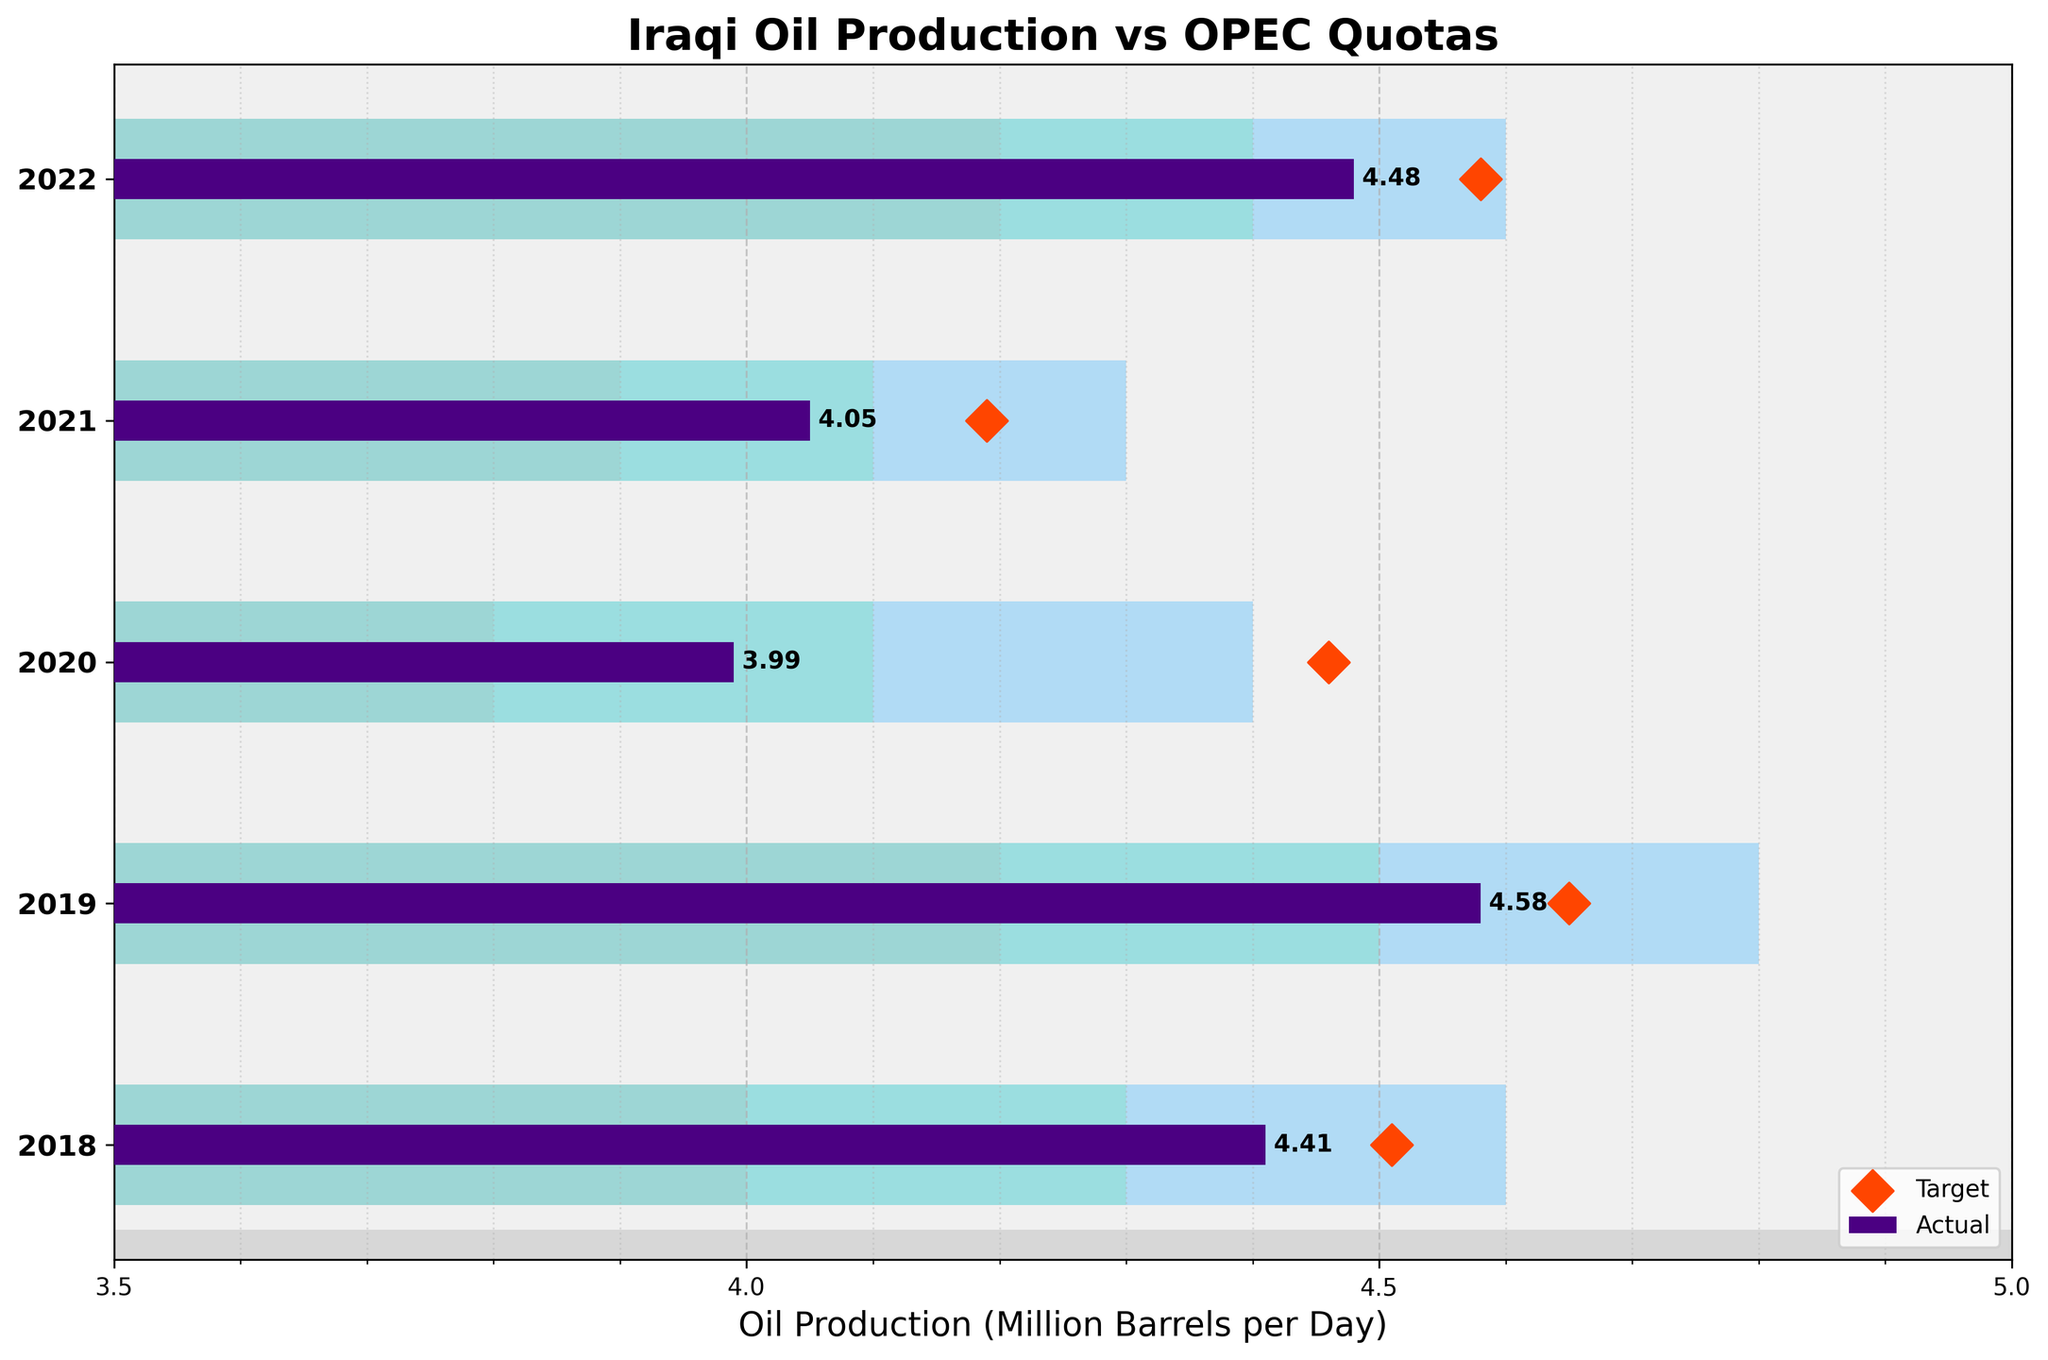What is the title of the figure? The title is usually located at the top of the figure. In this case, the title is "Iraqi Oil Production vs OPEC Quotas".
Answer: Iraqi Oil Production vs OPEC Quotas How many years of data are represented in the figure? The y-axis labels represent the categories, which are the years 2018, 2019, 2020, 2021, and 2022.
Answer: 5 What is the actual oil production value for 2019? The bar for 2019 corresponds to the value labeled on the x-axis just to the right of it. According to the labels, the value is 4.58 million barrels per day.
Answer: 4.58 million barrels per day What color represents the actual values in the figure? The legend indicates that the actual values are represented by a dark purple color in the figure.
Answer: Dark purple Which year had the highest actual oil production? By comparing the lengths of the dark purple bars, 2019 had the highest actual value, which is 4.58 million barrels per day.
Answer: 2019 For which year were actual oil production levels below all three thresholds? The actual production value should fall below the smallest threshold value. In 2020, the actual value (3.99) is below Threshold1 (3.8) because it is not represented beyond the light color gradient starting at 3.8.
Answer: 2020 How close was the actual value to the target in 2021? In 2021, the actual value is 4.05 and the target is 4.19. The difference is 4.19 - 4.05 = 0.14.
Answer: 0.14 million barrels per day In which year did Iraq exceed the target production quota? The actual production bar should extend beyond the target marker. In the figure, none of the purple bars are longer than the orange diamond markers. Thus, Iraq did not exceed its target production in any year.
Answer: None What is the overall trend of Iraqi oil production from 2018 to 2022? Evaluating the progression of the bars from 2018 to 2022 shows variability with a slight dip in 2020 and gradual recovery towards 2022, but no clear upward or downward trend.
Answer: Variable What is the smallest threshold value color? The thresholds are represented by three color shades. The smallest threshold value corresponds to the light red color based on the leftmost bar against the gray background.
Answer: Light red 